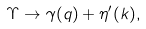Convert formula to latex. <formula><loc_0><loc_0><loc_500><loc_500>\Upsilon \to \gamma ( q ) + \eta ^ { \prime } ( k ) ,</formula> 